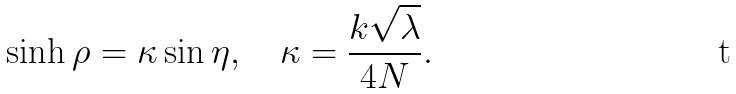<formula> <loc_0><loc_0><loc_500><loc_500>\sinh \rho = \kappa \sin \eta , \quad \kappa = \frac { k \sqrt { \lambda } } { 4 N } .</formula> 